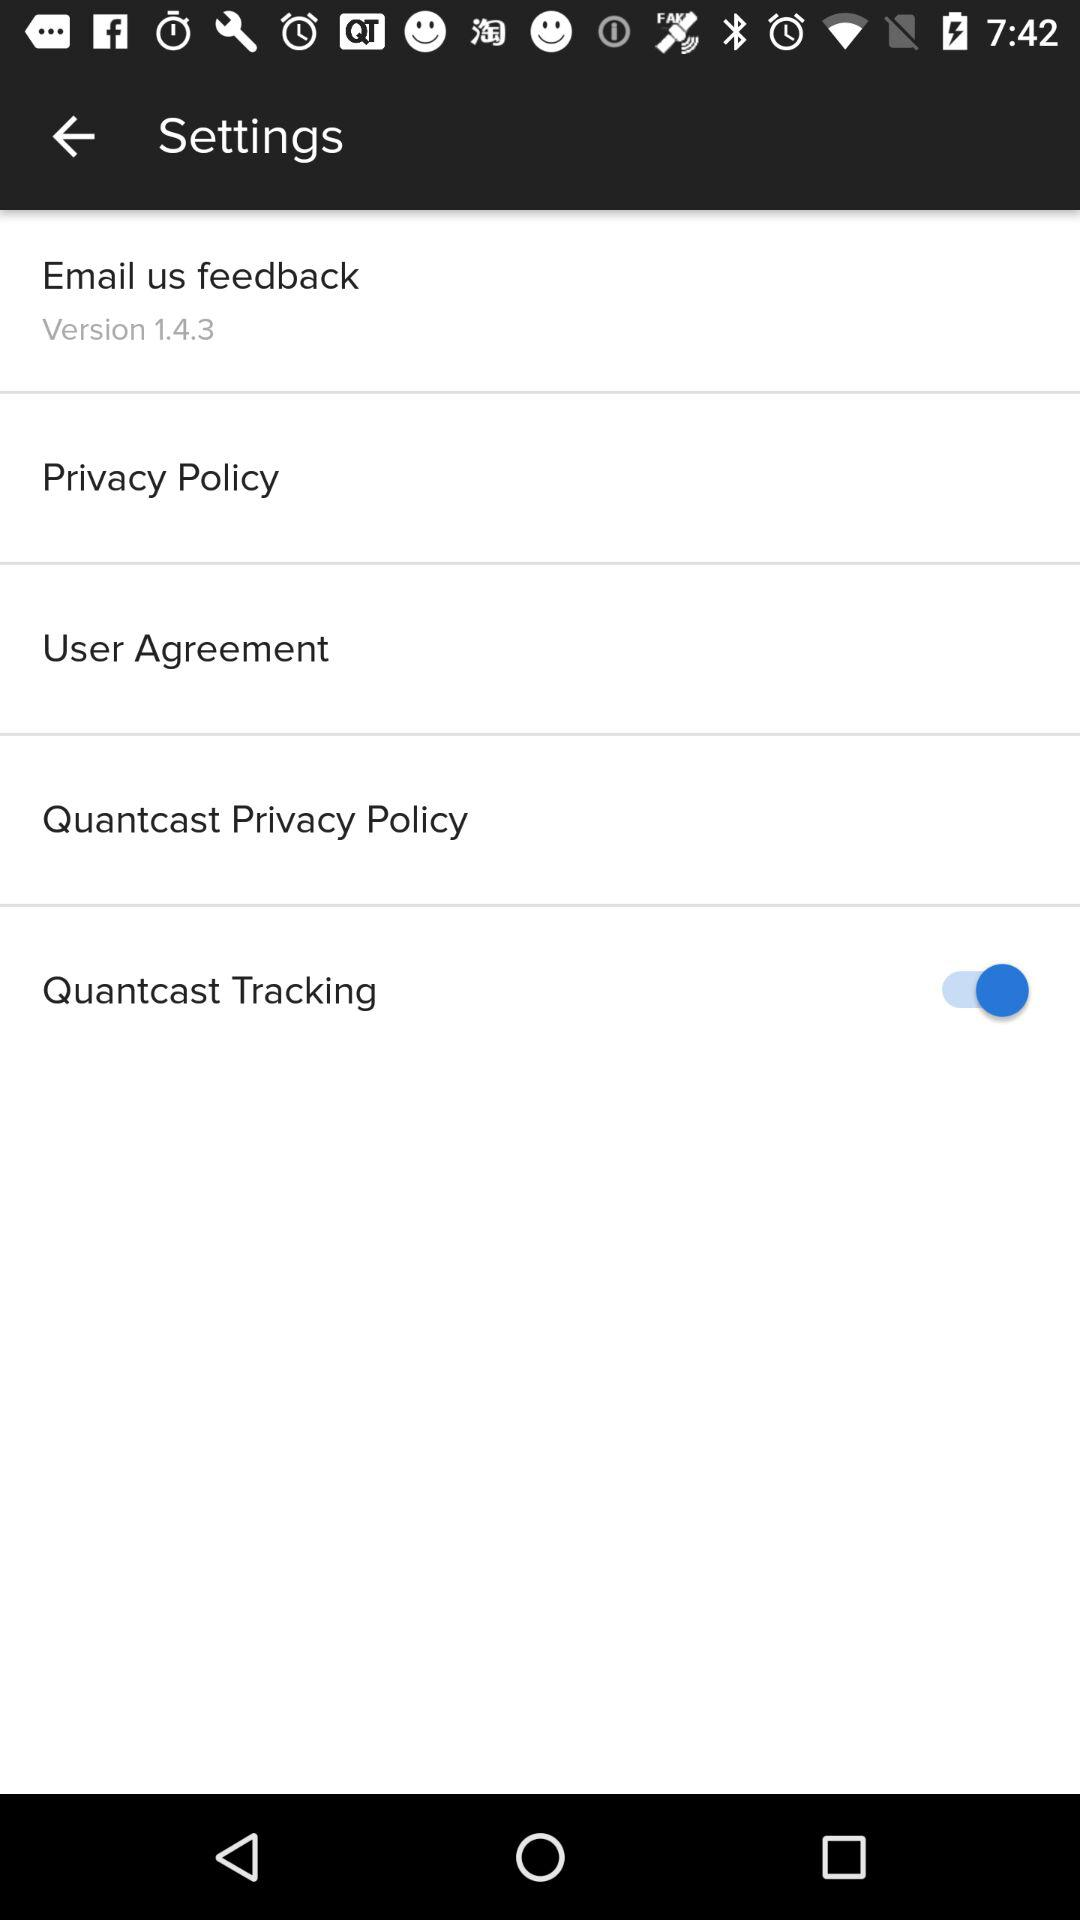What is the status of "Quantcast Tracking"? The status is "on". 